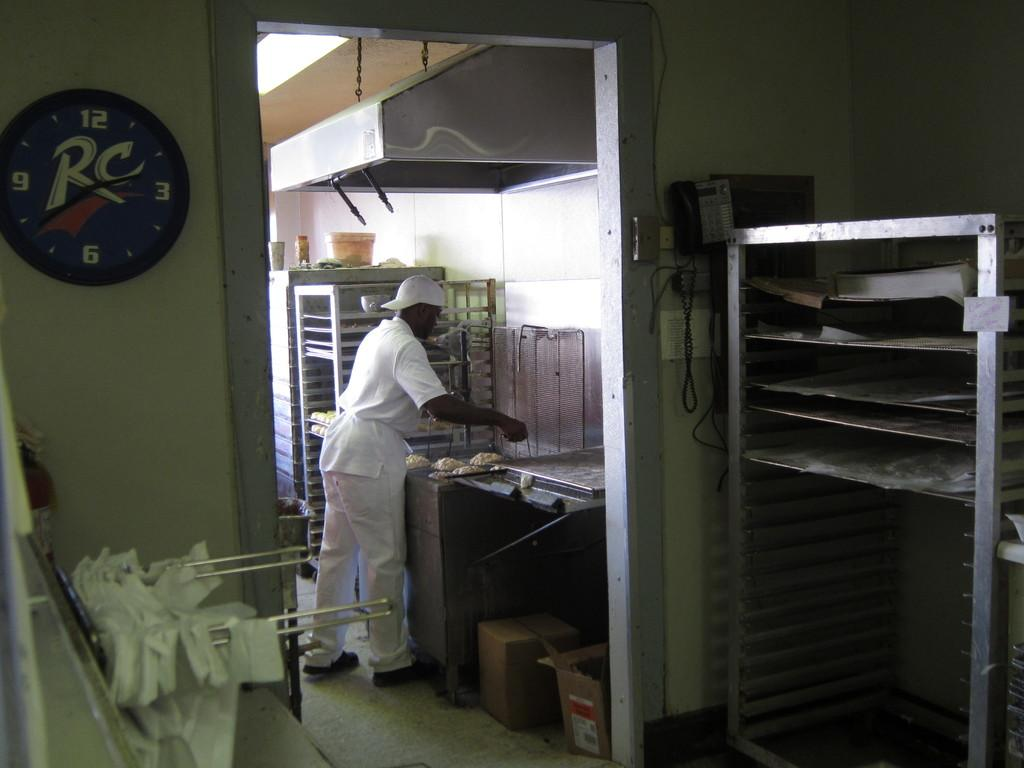Provide a one-sentence caption for the provided image. A man preparing some food in a kitchen with an RC clock. 